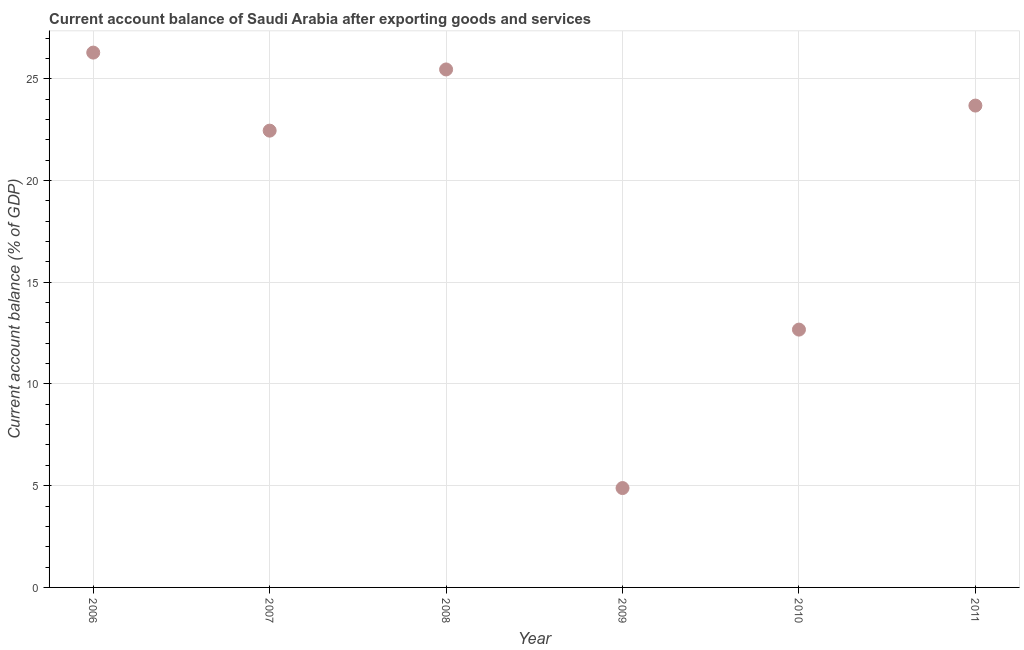What is the current account balance in 2011?
Your answer should be very brief. 23.68. Across all years, what is the maximum current account balance?
Provide a short and direct response. 26.28. Across all years, what is the minimum current account balance?
Ensure brevity in your answer.  4.88. In which year was the current account balance maximum?
Offer a terse response. 2006. In which year was the current account balance minimum?
Your answer should be compact. 2009. What is the sum of the current account balance?
Provide a short and direct response. 115.42. What is the difference between the current account balance in 2006 and 2011?
Make the answer very short. 2.6. What is the average current account balance per year?
Offer a very short reply. 19.24. What is the median current account balance?
Your response must be concise. 23.06. What is the ratio of the current account balance in 2007 to that in 2008?
Ensure brevity in your answer.  0.88. Is the difference between the current account balance in 2009 and 2011 greater than the difference between any two years?
Your answer should be compact. No. What is the difference between the highest and the second highest current account balance?
Offer a very short reply. 0.83. What is the difference between the highest and the lowest current account balance?
Ensure brevity in your answer.  21.4. How many dotlines are there?
Your answer should be compact. 1. What is the difference between two consecutive major ticks on the Y-axis?
Provide a short and direct response. 5. What is the title of the graph?
Your response must be concise. Current account balance of Saudi Arabia after exporting goods and services. What is the label or title of the X-axis?
Provide a short and direct response. Year. What is the label or title of the Y-axis?
Give a very brief answer. Current account balance (% of GDP). What is the Current account balance (% of GDP) in 2006?
Ensure brevity in your answer.  26.28. What is the Current account balance (% of GDP) in 2007?
Your answer should be very brief. 22.45. What is the Current account balance (% of GDP) in 2008?
Offer a terse response. 25.46. What is the Current account balance (% of GDP) in 2009?
Ensure brevity in your answer.  4.88. What is the Current account balance (% of GDP) in 2010?
Give a very brief answer. 12.67. What is the Current account balance (% of GDP) in 2011?
Keep it short and to the point. 23.68. What is the difference between the Current account balance (% of GDP) in 2006 and 2007?
Provide a succinct answer. 3.84. What is the difference between the Current account balance (% of GDP) in 2006 and 2008?
Provide a succinct answer. 0.83. What is the difference between the Current account balance (% of GDP) in 2006 and 2009?
Your answer should be compact. 21.4. What is the difference between the Current account balance (% of GDP) in 2006 and 2010?
Keep it short and to the point. 13.61. What is the difference between the Current account balance (% of GDP) in 2006 and 2011?
Give a very brief answer. 2.6. What is the difference between the Current account balance (% of GDP) in 2007 and 2008?
Offer a very short reply. -3.01. What is the difference between the Current account balance (% of GDP) in 2007 and 2009?
Ensure brevity in your answer.  17.57. What is the difference between the Current account balance (% of GDP) in 2007 and 2010?
Your answer should be compact. 9.78. What is the difference between the Current account balance (% of GDP) in 2007 and 2011?
Give a very brief answer. -1.23. What is the difference between the Current account balance (% of GDP) in 2008 and 2009?
Keep it short and to the point. 20.57. What is the difference between the Current account balance (% of GDP) in 2008 and 2010?
Provide a short and direct response. 12.79. What is the difference between the Current account balance (% of GDP) in 2008 and 2011?
Provide a succinct answer. 1.78. What is the difference between the Current account balance (% of GDP) in 2009 and 2010?
Keep it short and to the point. -7.79. What is the difference between the Current account balance (% of GDP) in 2009 and 2011?
Your response must be concise. -18.8. What is the difference between the Current account balance (% of GDP) in 2010 and 2011?
Give a very brief answer. -11.01. What is the ratio of the Current account balance (% of GDP) in 2006 to that in 2007?
Your answer should be compact. 1.17. What is the ratio of the Current account balance (% of GDP) in 2006 to that in 2008?
Your answer should be compact. 1.03. What is the ratio of the Current account balance (% of GDP) in 2006 to that in 2009?
Your response must be concise. 5.38. What is the ratio of the Current account balance (% of GDP) in 2006 to that in 2010?
Give a very brief answer. 2.07. What is the ratio of the Current account balance (% of GDP) in 2006 to that in 2011?
Keep it short and to the point. 1.11. What is the ratio of the Current account balance (% of GDP) in 2007 to that in 2008?
Your answer should be very brief. 0.88. What is the ratio of the Current account balance (% of GDP) in 2007 to that in 2009?
Provide a short and direct response. 4.6. What is the ratio of the Current account balance (% of GDP) in 2007 to that in 2010?
Your response must be concise. 1.77. What is the ratio of the Current account balance (% of GDP) in 2007 to that in 2011?
Make the answer very short. 0.95. What is the ratio of the Current account balance (% of GDP) in 2008 to that in 2009?
Give a very brief answer. 5.21. What is the ratio of the Current account balance (% of GDP) in 2008 to that in 2010?
Give a very brief answer. 2.01. What is the ratio of the Current account balance (% of GDP) in 2008 to that in 2011?
Ensure brevity in your answer.  1.07. What is the ratio of the Current account balance (% of GDP) in 2009 to that in 2010?
Your answer should be very brief. 0.39. What is the ratio of the Current account balance (% of GDP) in 2009 to that in 2011?
Your answer should be compact. 0.21. What is the ratio of the Current account balance (% of GDP) in 2010 to that in 2011?
Ensure brevity in your answer.  0.54. 